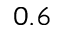<formula> <loc_0><loc_0><loc_500><loc_500>0 . 6</formula> 